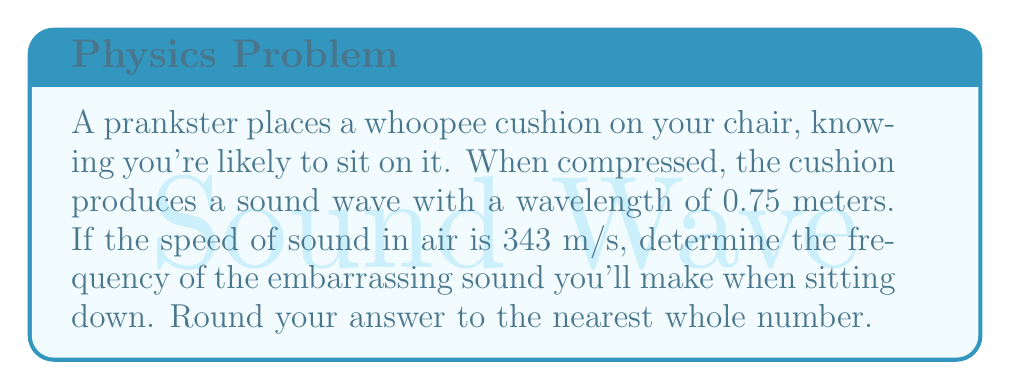Could you help me with this problem? To solve this problem, we'll use the wave equation that relates wavelength, frequency, and wave speed:

$$ v = f \lambda $$

Where:
$v$ = wave speed (speed of sound in air)
$f$ = frequency
$\lambda$ = wavelength

We're given:
$v = 343$ m/s
$\lambda = 0.75$ m

Let's solve for $f$:

$$ f = \frac{v}{\lambda} $$

Substituting the values:

$$ f = \frac{343 \text{ m/s}}{0.75 \text{ m}} $$

$$ f = 457.33 \text{ Hz} $$

Rounding to the nearest whole number:

$$ f \approx 457 \text{ Hz} $$

This means the whoopee cushion will produce a sound wave with a frequency of approximately 457 Hz when you sit on it, much to your embarrassment and your classmates' amusement.
Answer: 457 Hz 